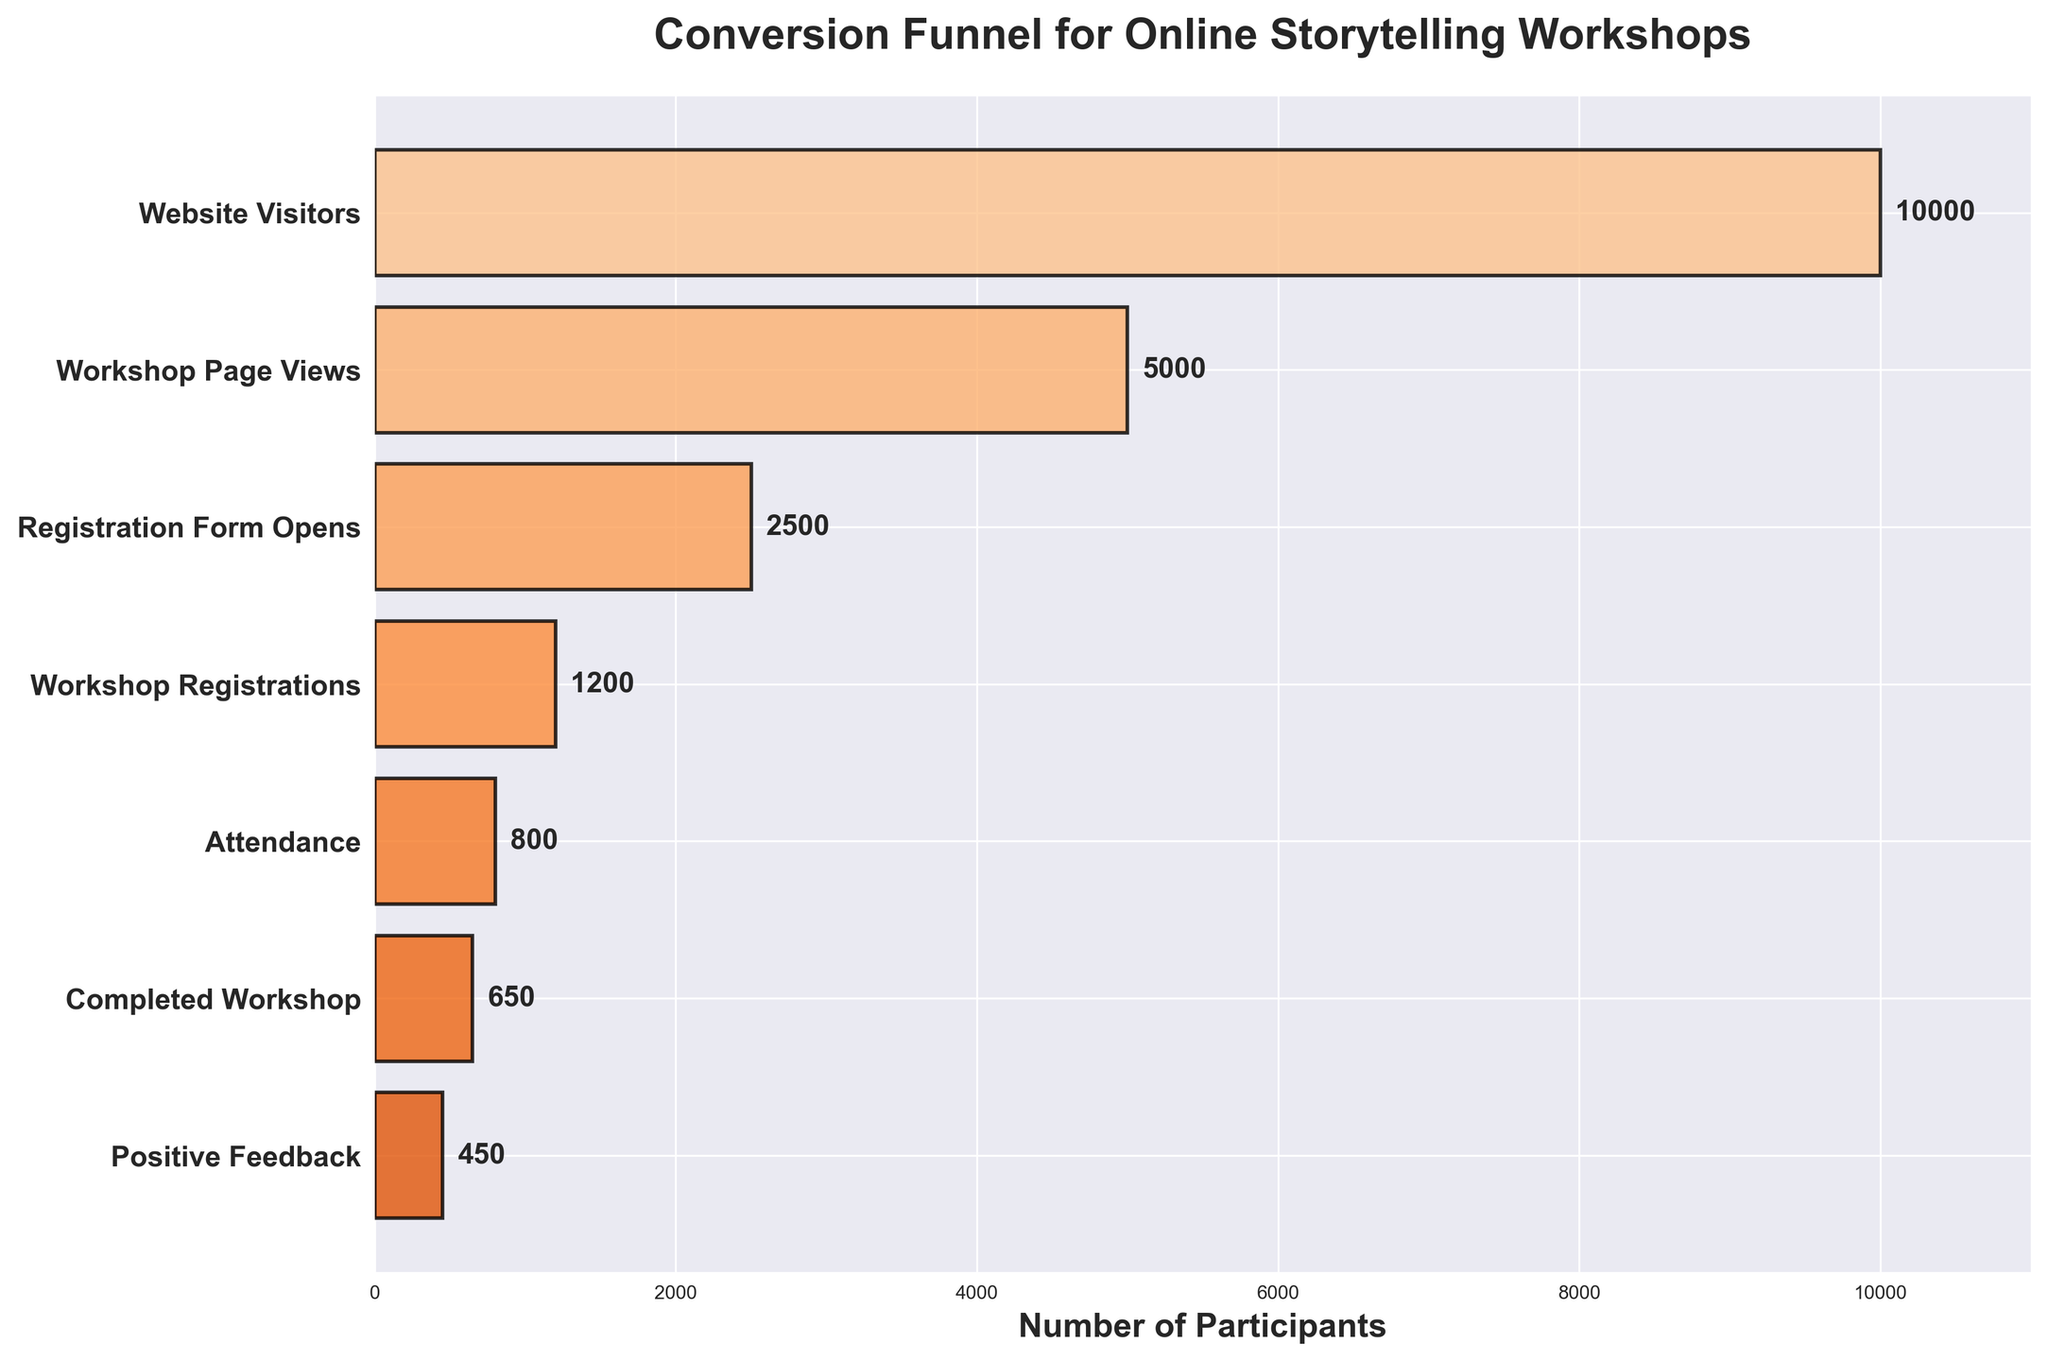What is the title of the figure? The title is located at the top of the figure, prominently displaying the main subject.
Answer: Conversion Funnel for Online Storytelling Workshops How many stages are shown in the funnel chart? Count the number of distinct labels on the vertical axis, which lists the different stages.
Answer: 7 What's the number of participants at the "Attendance" stage? Locate the "Attendance" label on the vertical axis, then check the corresponding bar for the number of participants indicated next to it.
Answer: 800 How many participants registered for the workshop? Find the stage labeled "Workshop Registrations" and refer to the number of participants shown next to it.
Answer: 1200 What's the sum of participants from the "Registration Form Opens" stage and the "Positive Feedback" stage? Locate the values for "Registration Form Opens" (2500) and "Positive Feedback" (450), then add them together: 2500 + 450 = 2950.
Answer: 2950 Which stage has the highest number of participants? Compare the participant numbers next to each stage. The stage with the highest number will be "Website Visitors."
Answer: Website Visitors Which stage showed the most significant drop in participants compared to the previous stage? Calculate the difference in participant numbers between consecutive stages and identify the largest drop: Website Visitors to Workshop Page Views (10000 - 5000 = 5000).
Answer: Website Visitors to Workshop Page Views What is the percentage of participants who gave positive feedback compared to those who completed the workshop? Divide the number of positive feedbacks by the number of completed workshops and multiply by 100: (450 / 650) * 100 ≈ 69.23%.
Answer: ~69.23% What percentage of website visitors attended the workshop? Divide the number of participants at the "Attendance" stage by the number at the "Website Visitors" stage and multiply by 100: (800 / 10000) * 100 = 8%.
Answer: 8% How does the "Workshop Page Views" stage compare to the "Workshop Registrations" stage in participant reduction percentage? Calculate the reduction as follows: [(5000 - 1200) / 5000] * 100 = 76%.
Answer: 76% 